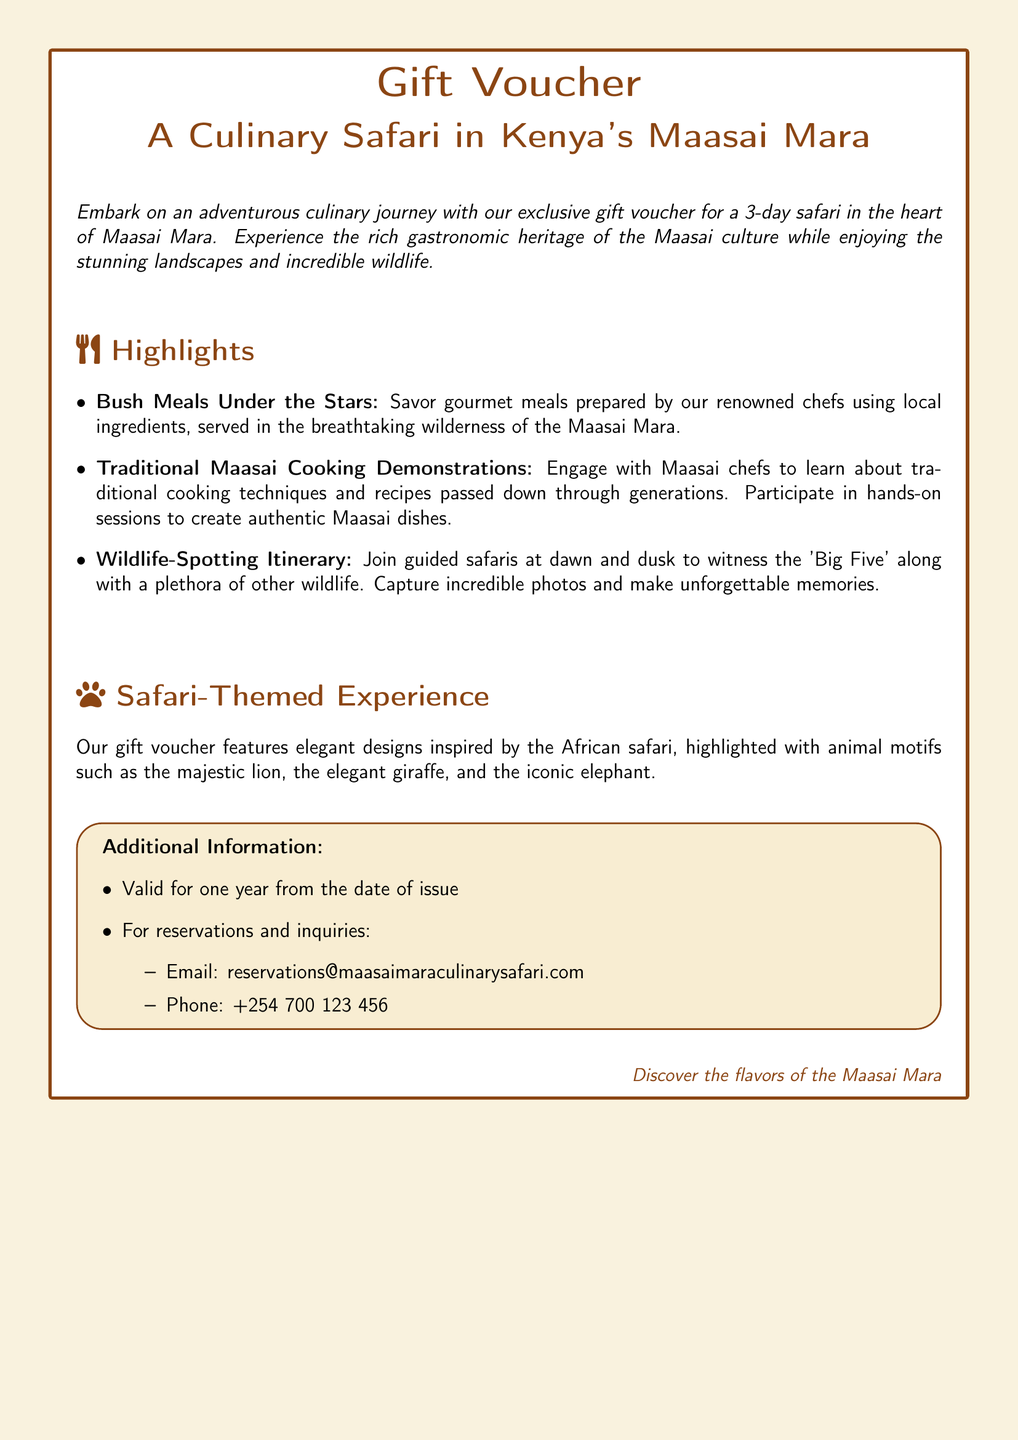What is the duration of the Culinary Safari? The document states that the Culinary Safari is for a duration of three days.
Answer: Three days What is the main culinary focus of the gift voucher? The gift voucher emphasizes experiencing the rich gastronomic heritage of the Maasai culture.
Answer: Maasai culture What type of meals are offered during the safari? The document specifies bush meals prepared by renowned chefs using local ingredients.
Answer: Bush Meals How long is the gift voucher valid for? According to the additional information, the gift voucher is valid for one year from the date of issue.
Answer: One year What wildlife is specifically mentioned for spotting during the safari? The document mentions the 'Big Five' as wildlife to be spotted during the safari.
Answer: Big Five What types of designs are featured on the gift voucher? The document describes safari-themed designs highlighted with animal motifs.
Answer: Safari-themed designs What is the email for reservations and inquiries? The document provides an email address for inquiries which is reservations@maasaimaraculinarysafari.com.
Answer: reservations@maasaimaraculinarysafari.com Which traditional cooking aspects are highlighted in the activities? The gift voucher mentions traditional Maasai cooking demonstrations as a key activity.
Answer: Cooking demonstrations 